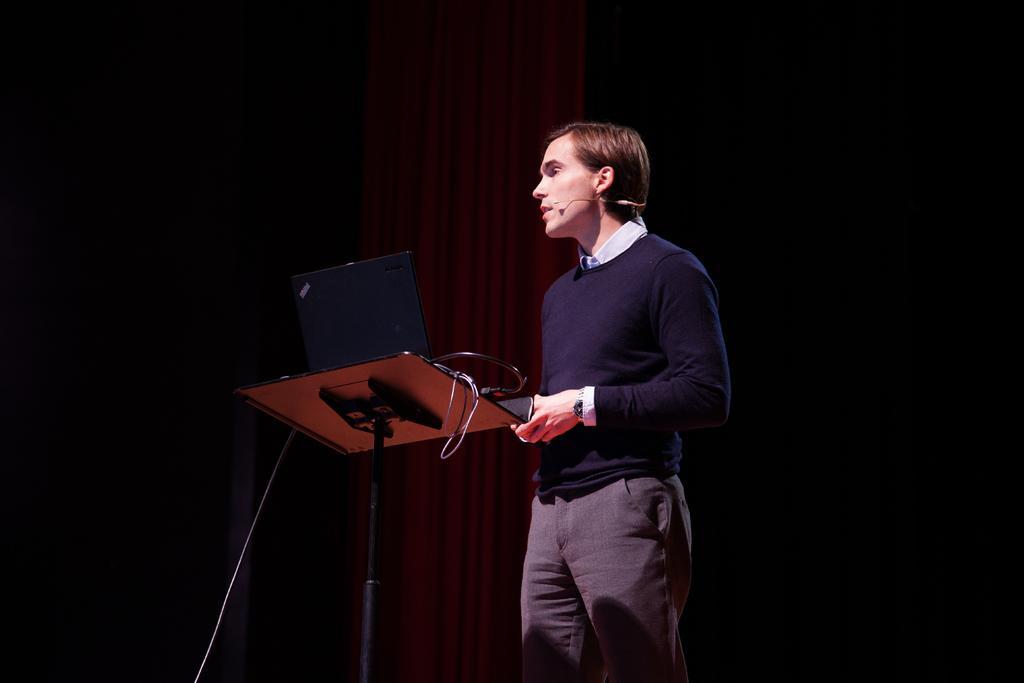Could you give a brief overview of what you see in this image? As we can see in the image there is a man wearing blue color jacket and there is an electrical equipment. 